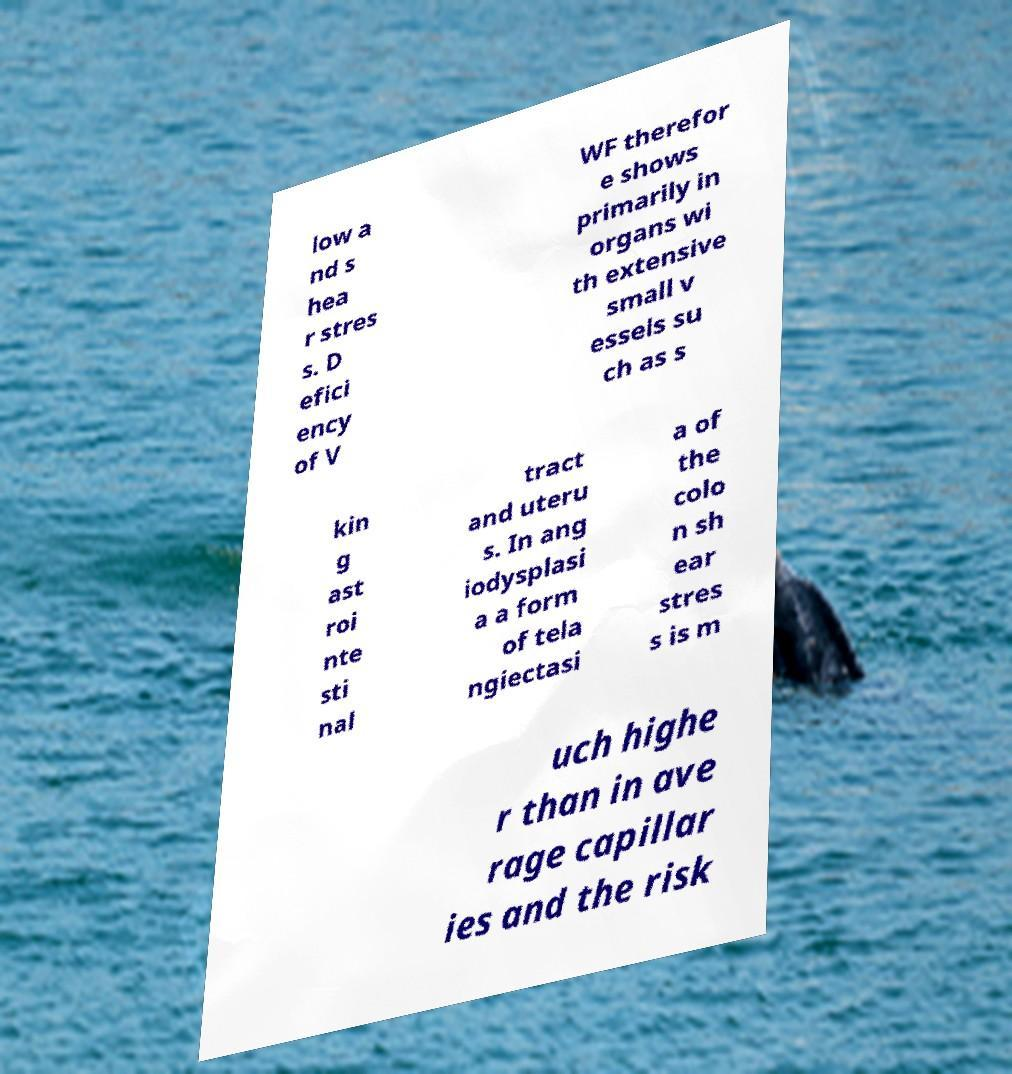Can you accurately transcribe the text from the provided image for me? low a nd s hea r stres s. D efici ency of V WF therefor e shows primarily in organs wi th extensive small v essels su ch as s kin g ast roi nte sti nal tract and uteru s. In ang iodysplasi a a form of tela ngiectasi a of the colo n sh ear stres s is m uch highe r than in ave rage capillar ies and the risk 